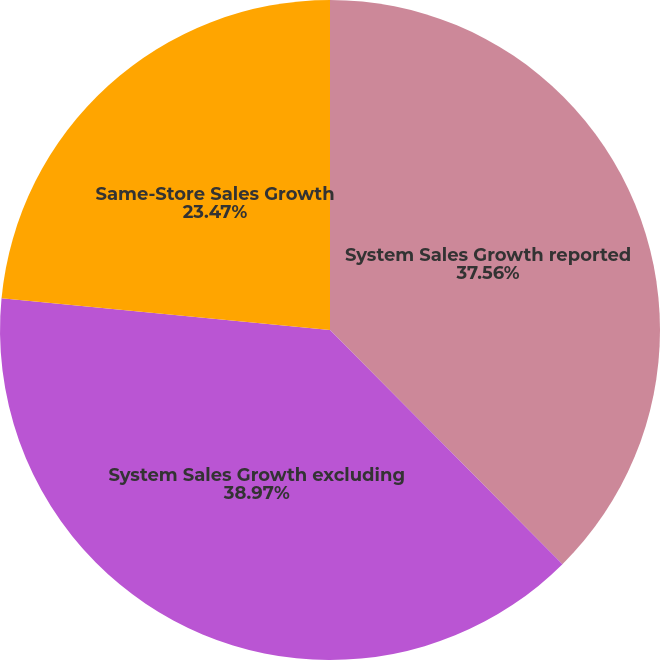Convert chart. <chart><loc_0><loc_0><loc_500><loc_500><pie_chart><fcel>System Sales Growth reported<fcel>System Sales Growth excluding<fcel>Same-Store Sales Growth<nl><fcel>37.56%<fcel>38.97%<fcel>23.47%<nl></chart> 